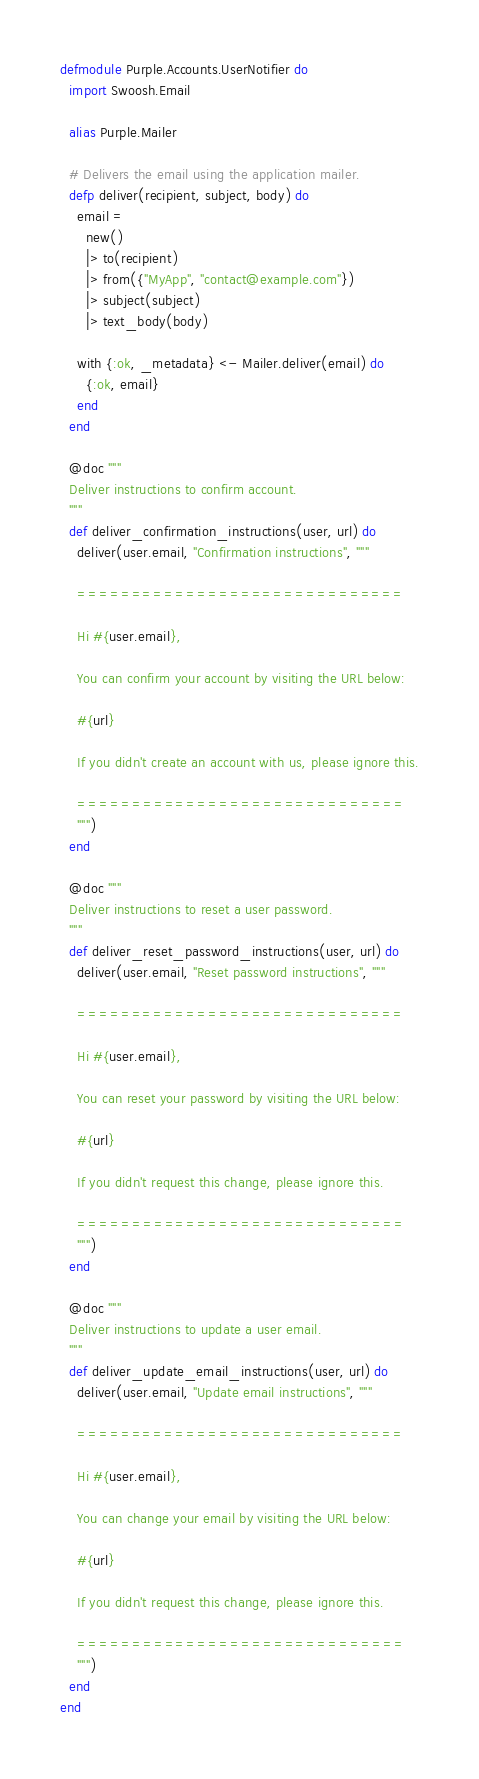<code> <loc_0><loc_0><loc_500><loc_500><_Elixir_>defmodule Purple.Accounts.UserNotifier do
  import Swoosh.Email

  alias Purple.Mailer

  # Delivers the email using the application mailer.
  defp deliver(recipient, subject, body) do
    email =
      new()
      |> to(recipient)
      |> from({"MyApp", "contact@example.com"})
      |> subject(subject)
      |> text_body(body)

    with {:ok, _metadata} <- Mailer.deliver(email) do
      {:ok, email}
    end
  end

  @doc """
  Deliver instructions to confirm account.
  """
  def deliver_confirmation_instructions(user, url) do
    deliver(user.email, "Confirmation instructions", """

    ==============================

    Hi #{user.email},

    You can confirm your account by visiting the URL below:

    #{url}

    If you didn't create an account with us, please ignore this.

    ==============================
    """)
  end

  @doc """
  Deliver instructions to reset a user password.
  """
  def deliver_reset_password_instructions(user, url) do
    deliver(user.email, "Reset password instructions", """

    ==============================

    Hi #{user.email},

    You can reset your password by visiting the URL below:

    #{url}

    If you didn't request this change, please ignore this.

    ==============================
    """)
  end

  @doc """
  Deliver instructions to update a user email.
  """
  def deliver_update_email_instructions(user, url) do
    deliver(user.email, "Update email instructions", """

    ==============================

    Hi #{user.email},

    You can change your email by visiting the URL below:

    #{url}

    If you didn't request this change, please ignore this.

    ==============================
    """)
  end
end
</code> 